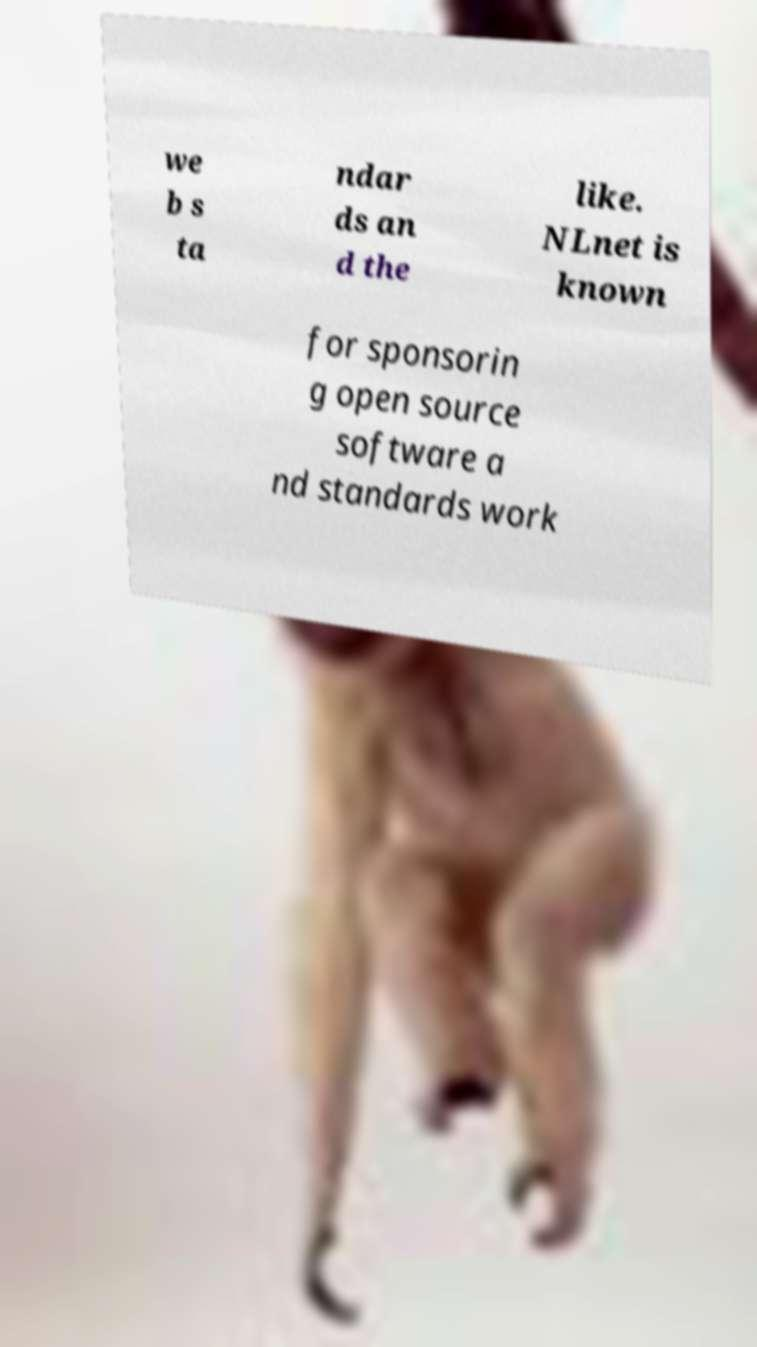Can you accurately transcribe the text from the provided image for me? we b s ta ndar ds an d the like. NLnet is known for sponsorin g open source software a nd standards work 